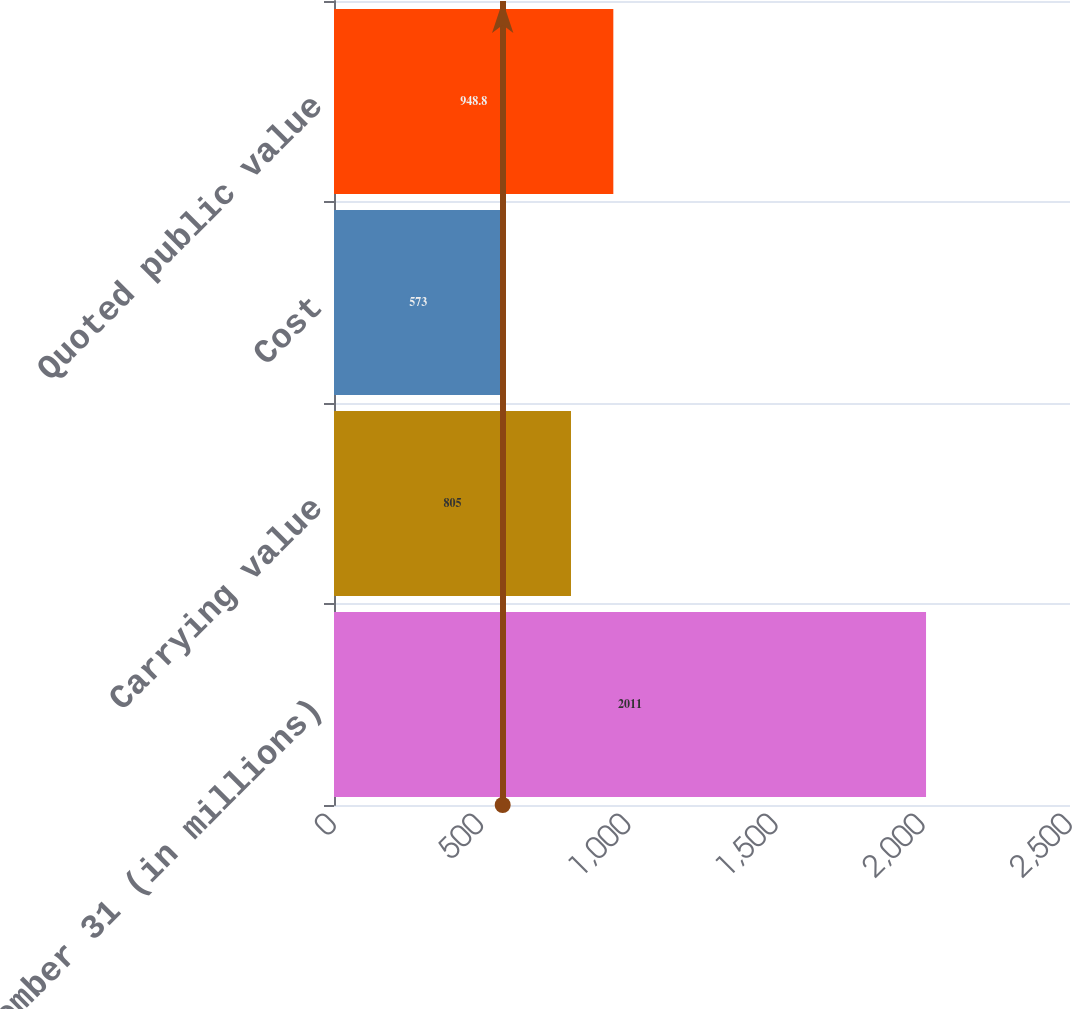<chart> <loc_0><loc_0><loc_500><loc_500><bar_chart><fcel>December 31 (in millions)<fcel>Carrying value<fcel>Cost<fcel>Quoted public value<nl><fcel>2011<fcel>805<fcel>573<fcel>948.8<nl></chart> 